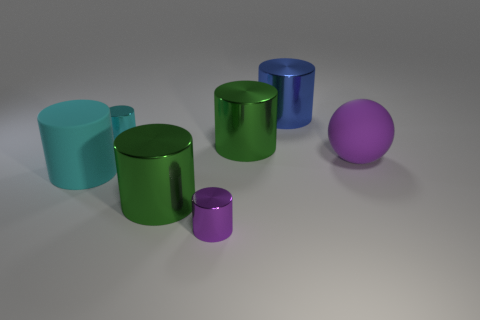Subtract all purple cylinders. How many cylinders are left? 5 Subtract all green cylinders. How many cylinders are left? 4 Subtract all red cylinders. Subtract all green cubes. How many cylinders are left? 6 Add 2 tiny purple metal things. How many objects exist? 9 Subtract all balls. How many objects are left? 6 Subtract all cylinders. Subtract all tiny matte spheres. How many objects are left? 1 Add 4 small cylinders. How many small cylinders are left? 6 Add 5 tiny gray matte spheres. How many tiny gray matte spheres exist? 5 Subtract 1 blue cylinders. How many objects are left? 6 